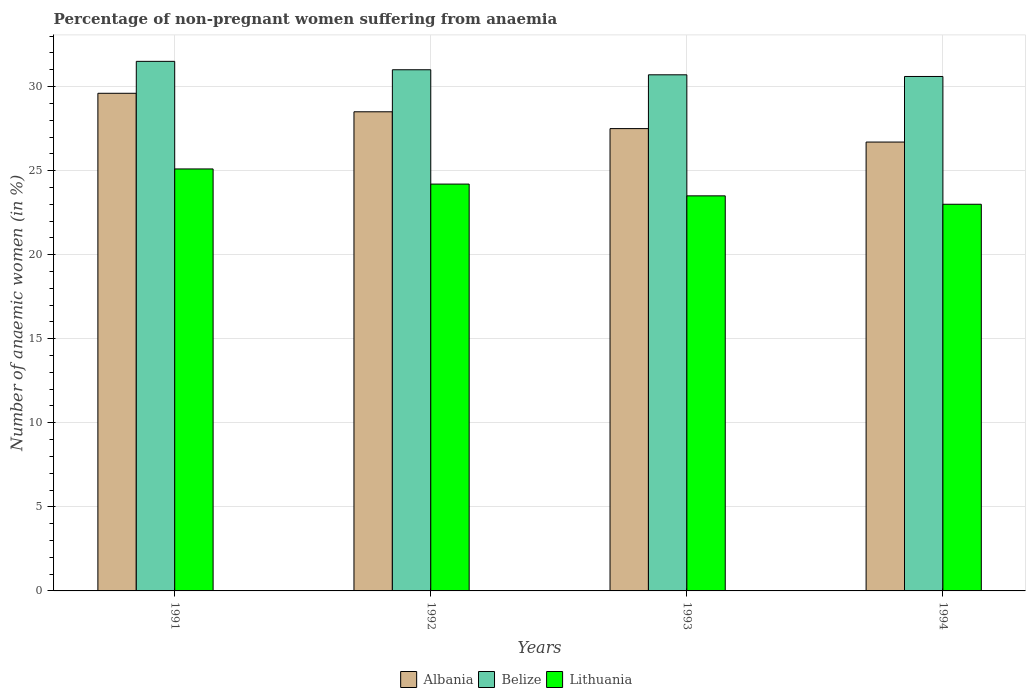Are the number of bars per tick equal to the number of legend labels?
Provide a succinct answer. Yes. Are the number of bars on each tick of the X-axis equal?
Your response must be concise. Yes. Across all years, what is the maximum percentage of non-pregnant women suffering from anaemia in Albania?
Keep it short and to the point. 29.6. Across all years, what is the minimum percentage of non-pregnant women suffering from anaemia in Belize?
Your answer should be compact. 30.6. In which year was the percentage of non-pregnant women suffering from anaemia in Lithuania maximum?
Ensure brevity in your answer.  1991. What is the total percentage of non-pregnant women suffering from anaemia in Albania in the graph?
Your answer should be compact. 112.3. What is the difference between the percentage of non-pregnant women suffering from anaemia in Albania in 1991 and that in 1993?
Provide a succinct answer. 2.1. What is the difference between the percentage of non-pregnant women suffering from anaemia in Lithuania in 1991 and the percentage of non-pregnant women suffering from anaemia in Belize in 1994?
Your response must be concise. -5.5. What is the average percentage of non-pregnant women suffering from anaemia in Lithuania per year?
Provide a succinct answer. 23.95. In the year 1993, what is the difference between the percentage of non-pregnant women suffering from anaemia in Albania and percentage of non-pregnant women suffering from anaemia in Belize?
Offer a very short reply. -3.2. In how many years, is the percentage of non-pregnant women suffering from anaemia in Lithuania greater than 3 %?
Give a very brief answer. 4. What is the ratio of the percentage of non-pregnant women suffering from anaemia in Belize in 1992 to that in 1994?
Make the answer very short. 1.01. Is the difference between the percentage of non-pregnant women suffering from anaemia in Albania in 1992 and 1993 greater than the difference between the percentage of non-pregnant women suffering from anaemia in Belize in 1992 and 1993?
Give a very brief answer. Yes. What is the difference between the highest and the second highest percentage of non-pregnant women suffering from anaemia in Lithuania?
Your response must be concise. 0.9. What is the difference between the highest and the lowest percentage of non-pregnant women suffering from anaemia in Lithuania?
Your response must be concise. 2.1. In how many years, is the percentage of non-pregnant women suffering from anaemia in Lithuania greater than the average percentage of non-pregnant women suffering from anaemia in Lithuania taken over all years?
Your response must be concise. 2. Is the sum of the percentage of non-pregnant women suffering from anaemia in Belize in 1991 and 1993 greater than the maximum percentage of non-pregnant women suffering from anaemia in Albania across all years?
Make the answer very short. Yes. What does the 3rd bar from the left in 1992 represents?
Provide a succinct answer. Lithuania. What does the 2nd bar from the right in 1994 represents?
Offer a terse response. Belize. Is it the case that in every year, the sum of the percentage of non-pregnant women suffering from anaemia in Albania and percentage of non-pregnant women suffering from anaemia in Lithuania is greater than the percentage of non-pregnant women suffering from anaemia in Belize?
Offer a very short reply. Yes. How many bars are there?
Provide a short and direct response. 12. Are all the bars in the graph horizontal?
Provide a succinct answer. No. What is the difference between two consecutive major ticks on the Y-axis?
Your answer should be very brief. 5. Does the graph contain grids?
Offer a terse response. Yes. How many legend labels are there?
Your answer should be compact. 3. How are the legend labels stacked?
Offer a very short reply. Horizontal. What is the title of the graph?
Provide a succinct answer. Percentage of non-pregnant women suffering from anaemia. What is the label or title of the Y-axis?
Provide a short and direct response. Number of anaemic women (in %). What is the Number of anaemic women (in %) of Albania in 1991?
Offer a terse response. 29.6. What is the Number of anaemic women (in %) of Belize in 1991?
Ensure brevity in your answer.  31.5. What is the Number of anaemic women (in %) in Lithuania in 1991?
Give a very brief answer. 25.1. What is the Number of anaemic women (in %) in Albania in 1992?
Your answer should be compact. 28.5. What is the Number of anaemic women (in %) of Lithuania in 1992?
Your answer should be very brief. 24.2. What is the Number of anaemic women (in %) in Albania in 1993?
Offer a terse response. 27.5. What is the Number of anaemic women (in %) of Belize in 1993?
Offer a very short reply. 30.7. What is the Number of anaemic women (in %) in Albania in 1994?
Your response must be concise. 26.7. What is the Number of anaemic women (in %) in Belize in 1994?
Your answer should be very brief. 30.6. What is the Number of anaemic women (in %) of Lithuania in 1994?
Make the answer very short. 23. Across all years, what is the maximum Number of anaemic women (in %) in Albania?
Make the answer very short. 29.6. Across all years, what is the maximum Number of anaemic women (in %) of Belize?
Offer a terse response. 31.5. Across all years, what is the maximum Number of anaemic women (in %) in Lithuania?
Your answer should be compact. 25.1. Across all years, what is the minimum Number of anaemic women (in %) in Albania?
Ensure brevity in your answer.  26.7. Across all years, what is the minimum Number of anaemic women (in %) in Belize?
Your response must be concise. 30.6. What is the total Number of anaemic women (in %) in Albania in the graph?
Ensure brevity in your answer.  112.3. What is the total Number of anaemic women (in %) of Belize in the graph?
Make the answer very short. 123.8. What is the total Number of anaemic women (in %) in Lithuania in the graph?
Make the answer very short. 95.8. What is the difference between the Number of anaemic women (in %) in Albania in 1991 and that in 1992?
Keep it short and to the point. 1.1. What is the difference between the Number of anaemic women (in %) in Belize in 1991 and that in 1993?
Your answer should be very brief. 0.8. What is the difference between the Number of anaemic women (in %) in Lithuania in 1991 and that in 1993?
Give a very brief answer. 1.6. What is the difference between the Number of anaemic women (in %) in Albania in 1991 and that in 1994?
Make the answer very short. 2.9. What is the difference between the Number of anaemic women (in %) in Belize in 1992 and that in 1993?
Give a very brief answer. 0.3. What is the difference between the Number of anaemic women (in %) in Lithuania in 1992 and that in 1993?
Provide a short and direct response. 0.7. What is the difference between the Number of anaemic women (in %) in Belize in 1992 and that in 1994?
Provide a succinct answer. 0.4. What is the difference between the Number of anaemic women (in %) of Lithuania in 1993 and that in 1994?
Your answer should be compact. 0.5. What is the difference between the Number of anaemic women (in %) of Albania in 1991 and the Number of anaemic women (in %) of Belize in 1992?
Provide a short and direct response. -1.4. What is the difference between the Number of anaemic women (in %) of Albania in 1991 and the Number of anaemic women (in %) of Lithuania in 1992?
Offer a terse response. 5.4. What is the difference between the Number of anaemic women (in %) in Albania in 1991 and the Number of anaemic women (in %) in Lithuania in 1993?
Offer a terse response. 6.1. What is the difference between the Number of anaemic women (in %) in Belize in 1991 and the Number of anaemic women (in %) in Lithuania in 1993?
Offer a terse response. 8. What is the difference between the Number of anaemic women (in %) of Albania in 1991 and the Number of anaemic women (in %) of Belize in 1994?
Keep it short and to the point. -1. What is the difference between the Number of anaemic women (in %) in Albania in 1992 and the Number of anaemic women (in %) in Belize in 1993?
Provide a succinct answer. -2.2. What is the difference between the Number of anaemic women (in %) of Belize in 1992 and the Number of anaemic women (in %) of Lithuania in 1993?
Keep it short and to the point. 7.5. What is the difference between the Number of anaemic women (in %) in Albania in 1993 and the Number of anaemic women (in %) in Belize in 1994?
Your answer should be very brief. -3.1. What is the difference between the Number of anaemic women (in %) of Albania in 1993 and the Number of anaemic women (in %) of Lithuania in 1994?
Your answer should be compact. 4.5. What is the average Number of anaemic women (in %) in Albania per year?
Give a very brief answer. 28.07. What is the average Number of anaemic women (in %) of Belize per year?
Your response must be concise. 30.95. What is the average Number of anaemic women (in %) of Lithuania per year?
Provide a short and direct response. 23.95. In the year 1991, what is the difference between the Number of anaemic women (in %) of Albania and Number of anaemic women (in %) of Lithuania?
Your answer should be very brief. 4.5. In the year 1992, what is the difference between the Number of anaemic women (in %) of Albania and Number of anaemic women (in %) of Lithuania?
Offer a very short reply. 4.3. In the year 1993, what is the difference between the Number of anaemic women (in %) in Albania and Number of anaemic women (in %) in Belize?
Offer a terse response. -3.2. In the year 1993, what is the difference between the Number of anaemic women (in %) in Albania and Number of anaemic women (in %) in Lithuania?
Provide a short and direct response. 4. In the year 1993, what is the difference between the Number of anaemic women (in %) in Belize and Number of anaemic women (in %) in Lithuania?
Offer a terse response. 7.2. In the year 1994, what is the difference between the Number of anaemic women (in %) of Albania and Number of anaemic women (in %) of Belize?
Your answer should be very brief. -3.9. In the year 1994, what is the difference between the Number of anaemic women (in %) in Albania and Number of anaemic women (in %) in Lithuania?
Keep it short and to the point. 3.7. What is the ratio of the Number of anaemic women (in %) of Albania in 1991 to that in 1992?
Ensure brevity in your answer.  1.04. What is the ratio of the Number of anaemic women (in %) of Belize in 1991 to that in 1992?
Keep it short and to the point. 1.02. What is the ratio of the Number of anaemic women (in %) of Lithuania in 1991 to that in 1992?
Provide a succinct answer. 1.04. What is the ratio of the Number of anaemic women (in %) in Albania in 1991 to that in 1993?
Make the answer very short. 1.08. What is the ratio of the Number of anaemic women (in %) in Belize in 1991 to that in 1993?
Provide a succinct answer. 1.03. What is the ratio of the Number of anaemic women (in %) of Lithuania in 1991 to that in 1993?
Offer a terse response. 1.07. What is the ratio of the Number of anaemic women (in %) in Albania in 1991 to that in 1994?
Your answer should be compact. 1.11. What is the ratio of the Number of anaemic women (in %) of Belize in 1991 to that in 1994?
Ensure brevity in your answer.  1.03. What is the ratio of the Number of anaemic women (in %) of Lithuania in 1991 to that in 1994?
Your response must be concise. 1.09. What is the ratio of the Number of anaemic women (in %) in Albania in 1992 to that in 1993?
Your response must be concise. 1.04. What is the ratio of the Number of anaemic women (in %) of Belize in 1992 to that in 1993?
Provide a short and direct response. 1.01. What is the ratio of the Number of anaemic women (in %) of Lithuania in 1992 to that in 1993?
Provide a succinct answer. 1.03. What is the ratio of the Number of anaemic women (in %) in Albania in 1992 to that in 1994?
Make the answer very short. 1.07. What is the ratio of the Number of anaemic women (in %) of Belize in 1992 to that in 1994?
Provide a succinct answer. 1.01. What is the ratio of the Number of anaemic women (in %) of Lithuania in 1992 to that in 1994?
Your answer should be compact. 1.05. What is the ratio of the Number of anaemic women (in %) of Albania in 1993 to that in 1994?
Your response must be concise. 1.03. What is the ratio of the Number of anaemic women (in %) of Lithuania in 1993 to that in 1994?
Provide a short and direct response. 1.02. What is the difference between the highest and the second highest Number of anaemic women (in %) in Albania?
Provide a succinct answer. 1.1. What is the difference between the highest and the second highest Number of anaemic women (in %) of Belize?
Keep it short and to the point. 0.5. 